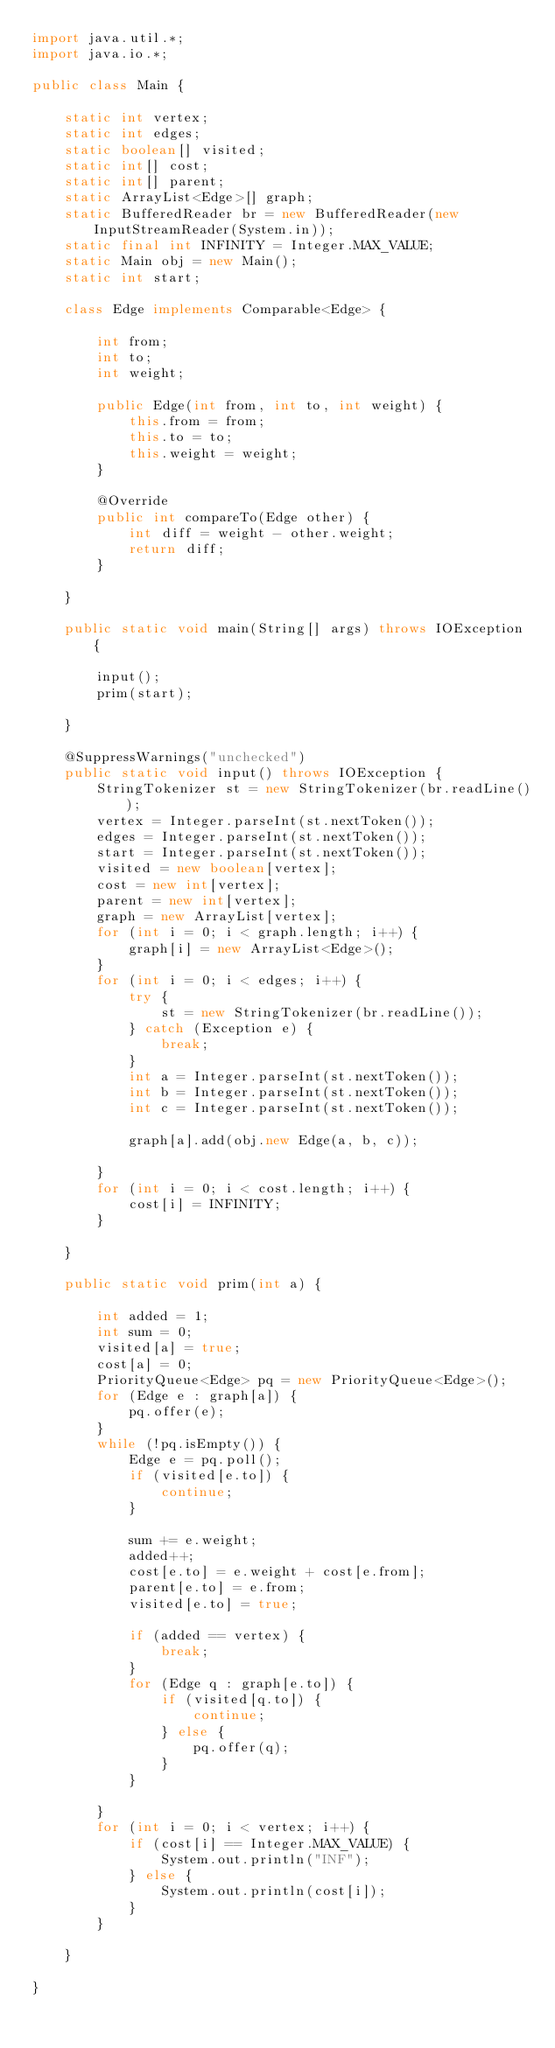Convert code to text. <code><loc_0><loc_0><loc_500><loc_500><_Java_>import java.util.*;
import java.io.*;

public class Main {

	static int vertex;
	static int edges;
	static boolean[] visited;
	static int[] cost;
	static int[] parent;
	static ArrayList<Edge>[] graph;
	static BufferedReader br = new BufferedReader(new InputStreamReader(System.in));
	static final int INFINITY = Integer.MAX_VALUE;
	static Main obj = new Main();
	static int start;

	class Edge implements Comparable<Edge> {

		int from;
		int to;
		int weight;

		public Edge(int from, int to, int weight) {
			this.from = from;
			this.to = to;
			this.weight = weight;
		}

		@Override
		public int compareTo(Edge other) {
			int diff = weight - other.weight;
			return diff;
		}

	}

	public static void main(String[] args) throws IOException {

		input();
		prim(start);

	}

	@SuppressWarnings("unchecked")
	public static void input() throws IOException {
		StringTokenizer st = new StringTokenizer(br.readLine());
		vertex = Integer.parseInt(st.nextToken());
		edges = Integer.parseInt(st.nextToken());
		start = Integer.parseInt(st.nextToken());
		visited = new boolean[vertex];
		cost = new int[vertex];
		parent = new int[vertex];
		graph = new ArrayList[vertex];
		for (int i = 0; i < graph.length; i++) {
			graph[i] = new ArrayList<Edge>();
		}
		for (int i = 0; i < edges; i++) {
			try {
				st = new StringTokenizer(br.readLine());
			} catch (Exception e) {
				break;
			}
			int a = Integer.parseInt(st.nextToken());
			int b = Integer.parseInt(st.nextToken());
			int c = Integer.parseInt(st.nextToken());

			graph[a].add(obj.new Edge(a, b, c));

		}
		for (int i = 0; i < cost.length; i++) {
			cost[i] = INFINITY;
		}

	}

	public static void prim(int a) {

		int added = 1;
		int sum = 0;
		visited[a] = true;
		cost[a] = 0;
		PriorityQueue<Edge> pq = new PriorityQueue<Edge>();
		for (Edge e : graph[a]) {
			pq.offer(e);
		}
		while (!pq.isEmpty()) {
			Edge e = pq.poll();
			if (visited[e.to]) {
				continue;
			}

			sum += e.weight;
			added++;
			cost[e.to] = e.weight + cost[e.from];
			parent[e.to] = e.from;
			visited[e.to] = true;

			if (added == vertex) {
				break;
			}
			for (Edge q : graph[e.to]) {
				if (visited[q.to]) {
					continue;
				} else {
					pq.offer(q);
				}
			}

		}
		for (int i = 0; i < vertex; i++) {
			if (cost[i] == Integer.MAX_VALUE) {
				System.out.println("INF");
			} else {
				System.out.println(cost[i]);
			}
		}

	}

}</code> 